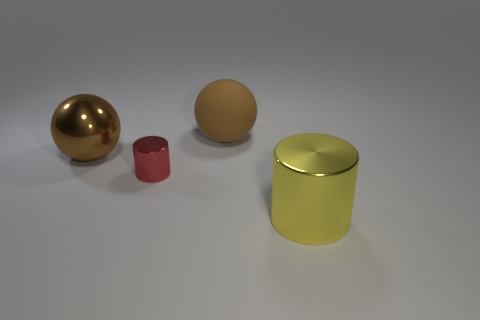What number of cylinders are tiny shiny things or big yellow shiny objects?
Offer a terse response. 2. Is the number of big brown metallic balls in front of the large brown shiny ball less than the number of big brown rubber spheres?
Provide a succinct answer. Yes. What number of other things are there of the same material as the yellow object
Offer a very short reply. 2. Is the yellow object the same size as the red cylinder?
Offer a terse response. No. How many objects are either big metal things behind the big yellow cylinder or big purple objects?
Offer a terse response. 1. What material is the large thing that is on the left side of the large brown rubber ball to the left of the large cylinder made of?
Offer a terse response. Metal. Is there a tiny rubber thing of the same shape as the big brown matte thing?
Your answer should be very brief. No. There is a red shiny thing; is its size the same as the brown thing behind the brown shiny thing?
Offer a terse response. No. What number of objects are large things that are on the left side of the tiny red cylinder or big metal things that are behind the red cylinder?
Offer a terse response. 1. Are there more red metallic things to the left of the red metal thing than shiny cylinders?
Make the answer very short. No. 